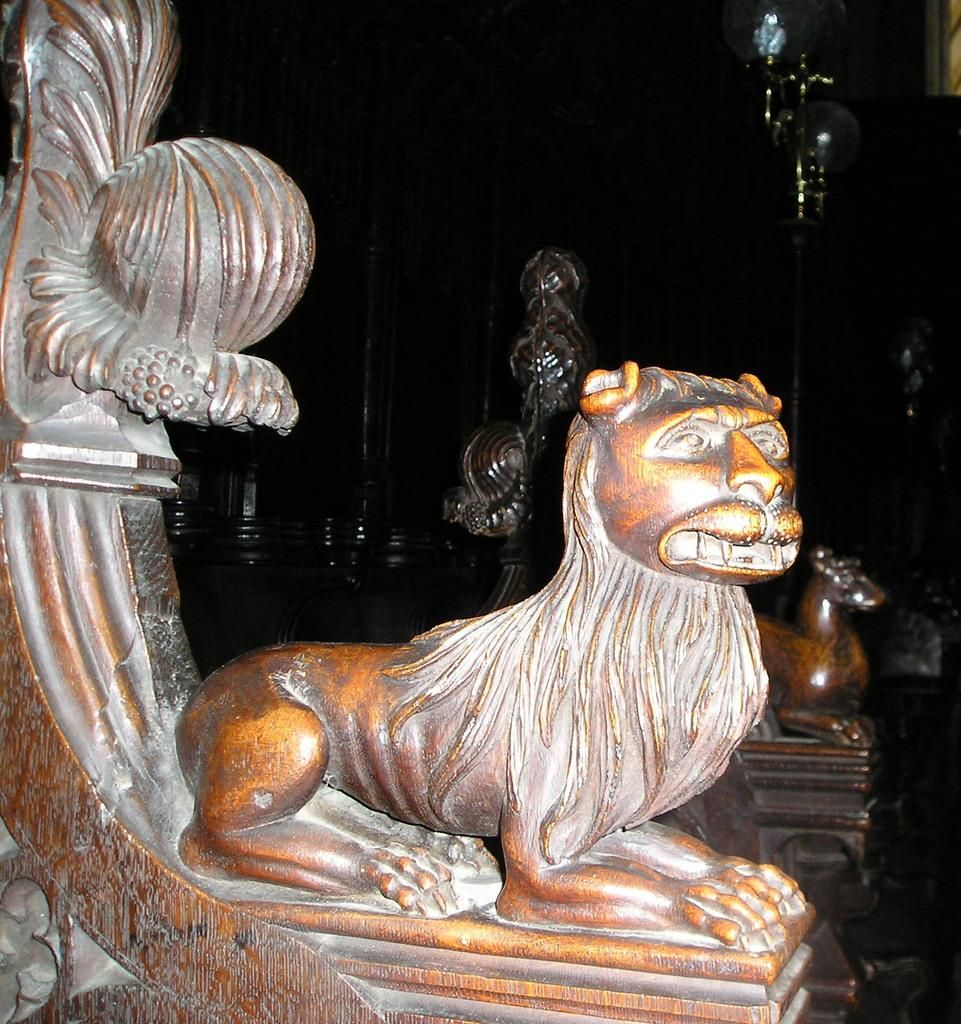What type of objects are depicted in the image? There are sculptures of animals in the image. Can you describe the background of the image? There are objects behind the animals in the image. What type of bun is being used to hold the animals together in the image? There is no bun present in the image; it features sculptures of animals without any bun. What is the income of the artist who created the sculptures in the image? The income of the artist is not mentioned or visible in the image, so it cannot be determined. 